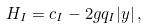Convert formula to latex. <formula><loc_0><loc_0><loc_500><loc_500>H _ { I } = c _ { I } - 2 g q _ { I } | y | \, ,</formula> 